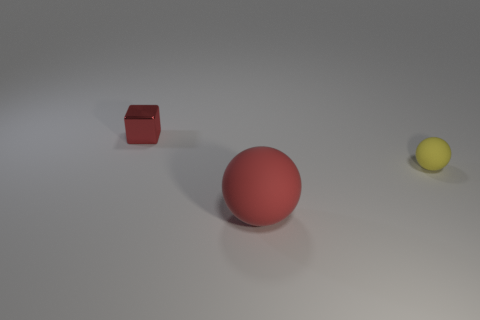Subtract all yellow balls. How many balls are left? 1 Subtract all spheres. How many objects are left? 1 Subtract 1 blocks. How many blocks are left? 0 Add 1 small purple blocks. How many objects exist? 4 Subtract all blue cubes. How many red spheres are left? 1 Subtract all small purple cylinders. Subtract all matte balls. How many objects are left? 1 Add 1 red rubber balls. How many red rubber balls are left? 2 Add 3 large cyan metal cubes. How many large cyan metal cubes exist? 3 Subtract 1 yellow spheres. How many objects are left? 2 Subtract all blue spheres. Subtract all blue blocks. How many spheres are left? 2 